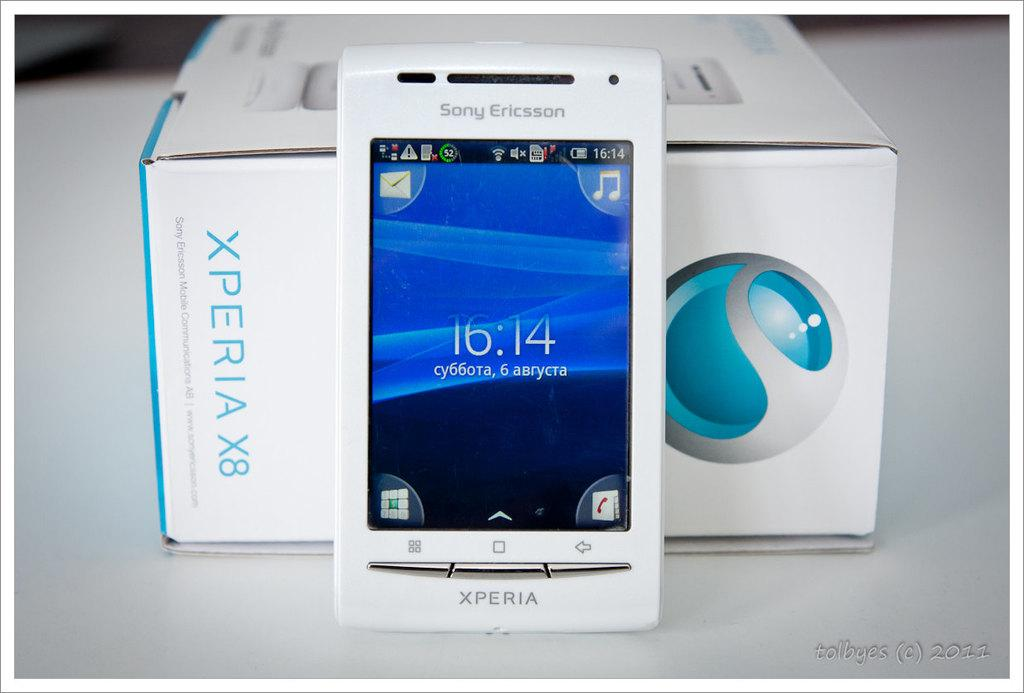Provide a one-sentence caption for the provided image. An Xperia smartphone by Sony Ericsson is displayed next to its box. 